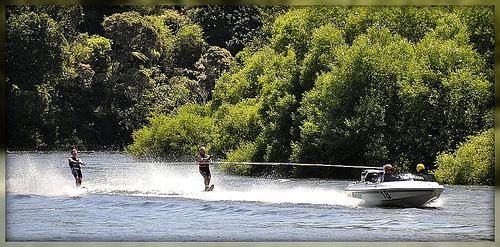What are the two doing behind the boat? Please explain your reasoning. water skiing. The two people behind the boat are water skiing. 